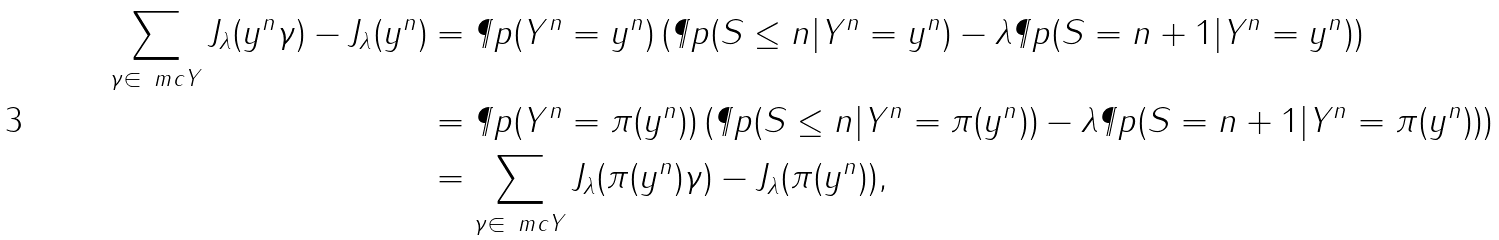<formula> <loc_0><loc_0><loc_500><loc_500>\sum _ { \gamma \in \ m c { Y } } J _ { \lambda } ( y ^ { n } \gamma ) - J _ { \lambda } ( y ^ { n } ) & = \P p ( Y ^ { n } = y ^ { n } ) \left ( \P p ( S \leq n | Y ^ { n } = y ^ { n } ) - \lambda \P p ( S = n + 1 | Y ^ { n } = y ^ { n } ) \right ) \\ & = \P p ( Y ^ { n } = \pi ( y ^ { n } ) ) \left ( \P p ( S \leq n | Y ^ { n } = \pi ( y ^ { n } ) ) - \lambda \P p ( S = n + 1 | Y ^ { n } = \pi ( y ^ { n } ) ) \right ) \\ & = \sum _ { \gamma \in \ m c { Y } } J _ { \lambda } ( \pi ( y ^ { n } ) \gamma ) - J _ { \lambda } ( \pi ( y ^ { n } ) ) ,</formula> 